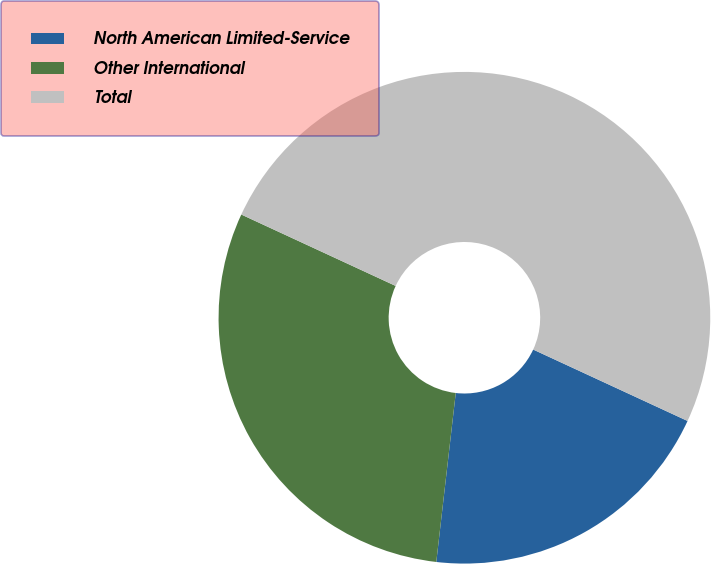Convert chart. <chart><loc_0><loc_0><loc_500><loc_500><pie_chart><fcel>North American Limited-Service<fcel>Other International<fcel>Total<nl><fcel>19.93%<fcel>30.07%<fcel>50.0%<nl></chart> 